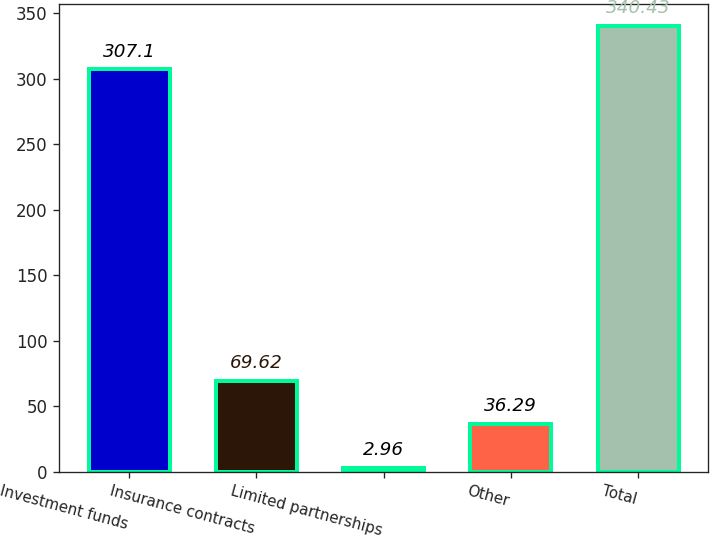Convert chart. <chart><loc_0><loc_0><loc_500><loc_500><bar_chart><fcel>Investment funds<fcel>Insurance contracts<fcel>Limited partnerships<fcel>Other<fcel>Total<nl><fcel>307.1<fcel>69.62<fcel>2.96<fcel>36.29<fcel>340.43<nl></chart> 